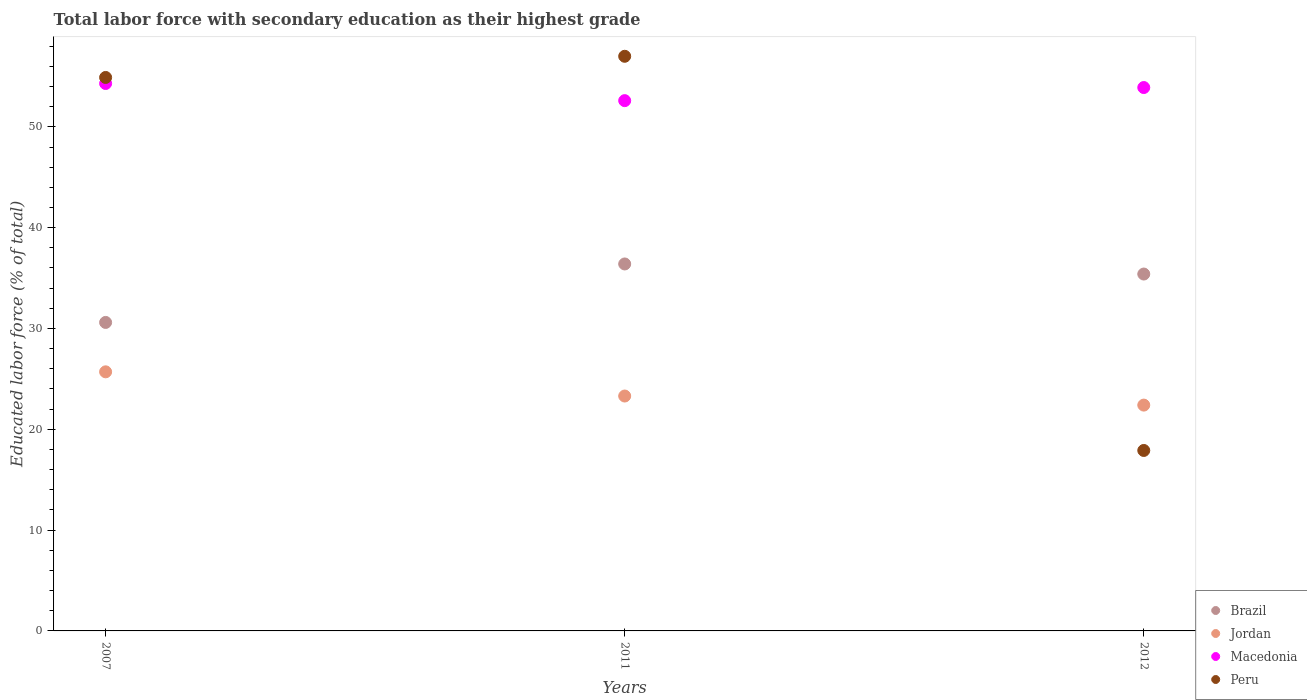How many different coloured dotlines are there?
Keep it short and to the point. 4. What is the percentage of total labor force with primary education in Brazil in 2011?
Make the answer very short. 36.4. Across all years, what is the maximum percentage of total labor force with primary education in Peru?
Provide a succinct answer. 57. Across all years, what is the minimum percentage of total labor force with primary education in Jordan?
Ensure brevity in your answer.  22.4. In which year was the percentage of total labor force with primary education in Peru maximum?
Offer a terse response. 2011. What is the total percentage of total labor force with primary education in Jordan in the graph?
Offer a terse response. 71.4. What is the difference between the percentage of total labor force with primary education in Peru in 2007 and that in 2012?
Your answer should be compact. 37. What is the difference between the percentage of total labor force with primary education in Peru in 2007 and the percentage of total labor force with primary education in Jordan in 2012?
Ensure brevity in your answer.  32.5. What is the average percentage of total labor force with primary education in Brazil per year?
Provide a short and direct response. 34.13. In the year 2012, what is the difference between the percentage of total labor force with primary education in Macedonia and percentage of total labor force with primary education in Jordan?
Your answer should be compact. 31.5. What is the ratio of the percentage of total labor force with primary education in Peru in 2007 to that in 2011?
Make the answer very short. 0.96. Is the percentage of total labor force with primary education in Macedonia in 2007 less than that in 2012?
Offer a terse response. No. What is the difference between the highest and the second highest percentage of total labor force with primary education in Jordan?
Provide a succinct answer. 2.4. What is the difference between the highest and the lowest percentage of total labor force with primary education in Jordan?
Offer a terse response. 3.3. In how many years, is the percentage of total labor force with primary education in Jordan greater than the average percentage of total labor force with primary education in Jordan taken over all years?
Your response must be concise. 1. Is it the case that in every year, the sum of the percentage of total labor force with primary education in Macedonia and percentage of total labor force with primary education in Brazil  is greater than the percentage of total labor force with primary education in Jordan?
Ensure brevity in your answer.  Yes. Does the percentage of total labor force with primary education in Jordan monotonically increase over the years?
Offer a terse response. No. Is the percentage of total labor force with primary education in Macedonia strictly greater than the percentage of total labor force with primary education in Brazil over the years?
Offer a very short reply. Yes. What is the difference between two consecutive major ticks on the Y-axis?
Offer a very short reply. 10. Are the values on the major ticks of Y-axis written in scientific E-notation?
Your answer should be compact. No. Does the graph contain any zero values?
Make the answer very short. No. How are the legend labels stacked?
Make the answer very short. Vertical. What is the title of the graph?
Your answer should be very brief. Total labor force with secondary education as their highest grade. What is the label or title of the X-axis?
Your answer should be compact. Years. What is the label or title of the Y-axis?
Provide a short and direct response. Educated labor force (% of total). What is the Educated labor force (% of total) in Brazil in 2007?
Ensure brevity in your answer.  30.6. What is the Educated labor force (% of total) of Jordan in 2007?
Ensure brevity in your answer.  25.7. What is the Educated labor force (% of total) of Macedonia in 2007?
Your answer should be very brief. 54.3. What is the Educated labor force (% of total) of Peru in 2007?
Your response must be concise. 54.9. What is the Educated labor force (% of total) of Brazil in 2011?
Offer a very short reply. 36.4. What is the Educated labor force (% of total) in Jordan in 2011?
Ensure brevity in your answer.  23.3. What is the Educated labor force (% of total) of Macedonia in 2011?
Provide a short and direct response. 52.6. What is the Educated labor force (% of total) in Brazil in 2012?
Offer a very short reply. 35.4. What is the Educated labor force (% of total) in Jordan in 2012?
Offer a very short reply. 22.4. What is the Educated labor force (% of total) in Macedonia in 2012?
Keep it short and to the point. 53.9. What is the Educated labor force (% of total) of Peru in 2012?
Offer a very short reply. 17.9. Across all years, what is the maximum Educated labor force (% of total) of Brazil?
Give a very brief answer. 36.4. Across all years, what is the maximum Educated labor force (% of total) in Jordan?
Keep it short and to the point. 25.7. Across all years, what is the maximum Educated labor force (% of total) of Macedonia?
Keep it short and to the point. 54.3. Across all years, what is the maximum Educated labor force (% of total) in Peru?
Your answer should be very brief. 57. Across all years, what is the minimum Educated labor force (% of total) of Brazil?
Your answer should be compact. 30.6. Across all years, what is the minimum Educated labor force (% of total) in Jordan?
Provide a short and direct response. 22.4. Across all years, what is the minimum Educated labor force (% of total) of Macedonia?
Provide a short and direct response. 52.6. Across all years, what is the minimum Educated labor force (% of total) of Peru?
Your answer should be very brief. 17.9. What is the total Educated labor force (% of total) of Brazil in the graph?
Provide a succinct answer. 102.4. What is the total Educated labor force (% of total) of Jordan in the graph?
Offer a very short reply. 71.4. What is the total Educated labor force (% of total) of Macedonia in the graph?
Offer a very short reply. 160.8. What is the total Educated labor force (% of total) in Peru in the graph?
Keep it short and to the point. 129.8. What is the difference between the Educated labor force (% of total) of Jordan in 2007 and that in 2011?
Provide a succinct answer. 2.4. What is the difference between the Educated labor force (% of total) of Peru in 2007 and that in 2011?
Your response must be concise. -2.1. What is the difference between the Educated labor force (% of total) of Macedonia in 2007 and that in 2012?
Provide a succinct answer. 0.4. What is the difference between the Educated labor force (% of total) in Peru in 2007 and that in 2012?
Your answer should be very brief. 37. What is the difference between the Educated labor force (% of total) in Jordan in 2011 and that in 2012?
Ensure brevity in your answer.  0.9. What is the difference between the Educated labor force (% of total) of Macedonia in 2011 and that in 2012?
Offer a terse response. -1.3. What is the difference between the Educated labor force (% of total) in Peru in 2011 and that in 2012?
Your response must be concise. 39.1. What is the difference between the Educated labor force (% of total) of Brazil in 2007 and the Educated labor force (% of total) of Peru in 2011?
Offer a very short reply. -26.4. What is the difference between the Educated labor force (% of total) in Jordan in 2007 and the Educated labor force (% of total) in Macedonia in 2011?
Offer a very short reply. -26.9. What is the difference between the Educated labor force (% of total) of Jordan in 2007 and the Educated labor force (% of total) of Peru in 2011?
Keep it short and to the point. -31.3. What is the difference between the Educated labor force (% of total) of Macedonia in 2007 and the Educated labor force (% of total) of Peru in 2011?
Offer a terse response. -2.7. What is the difference between the Educated labor force (% of total) in Brazil in 2007 and the Educated labor force (% of total) in Macedonia in 2012?
Your answer should be compact. -23.3. What is the difference between the Educated labor force (% of total) of Jordan in 2007 and the Educated labor force (% of total) of Macedonia in 2012?
Keep it short and to the point. -28.2. What is the difference between the Educated labor force (% of total) of Jordan in 2007 and the Educated labor force (% of total) of Peru in 2012?
Ensure brevity in your answer.  7.8. What is the difference between the Educated labor force (% of total) in Macedonia in 2007 and the Educated labor force (% of total) in Peru in 2012?
Provide a succinct answer. 36.4. What is the difference between the Educated labor force (% of total) in Brazil in 2011 and the Educated labor force (% of total) in Jordan in 2012?
Offer a terse response. 14. What is the difference between the Educated labor force (% of total) in Brazil in 2011 and the Educated labor force (% of total) in Macedonia in 2012?
Provide a short and direct response. -17.5. What is the difference between the Educated labor force (% of total) of Jordan in 2011 and the Educated labor force (% of total) of Macedonia in 2012?
Provide a short and direct response. -30.6. What is the difference between the Educated labor force (% of total) in Jordan in 2011 and the Educated labor force (% of total) in Peru in 2012?
Offer a very short reply. 5.4. What is the difference between the Educated labor force (% of total) in Macedonia in 2011 and the Educated labor force (% of total) in Peru in 2012?
Offer a very short reply. 34.7. What is the average Educated labor force (% of total) in Brazil per year?
Offer a very short reply. 34.13. What is the average Educated labor force (% of total) in Jordan per year?
Offer a very short reply. 23.8. What is the average Educated labor force (% of total) of Macedonia per year?
Your answer should be compact. 53.6. What is the average Educated labor force (% of total) of Peru per year?
Make the answer very short. 43.27. In the year 2007, what is the difference between the Educated labor force (% of total) of Brazil and Educated labor force (% of total) of Macedonia?
Ensure brevity in your answer.  -23.7. In the year 2007, what is the difference between the Educated labor force (% of total) of Brazil and Educated labor force (% of total) of Peru?
Provide a short and direct response. -24.3. In the year 2007, what is the difference between the Educated labor force (% of total) in Jordan and Educated labor force (% of total) in Macedonia?
Your response must be concise. -28.6. In the year 2007, what is the difference between the Educated labor force (% of total) in Jordan and Educated labor force (% of total) in Peru?
Ensure brevity in your answer.  -29.2. In the year 2007, what is the difference between the Educated labor force (% of total) in Macedonia and Educated labor force (% of total) in Peru?
Provide a succinct answer. -0.6. In the year 2011, what is the difference between the Educated labor force (% of total) of Brazil and Educated labor force (% of total) of Jordan?
Give a very brief answer. 13.1. In the year 2011, what is the difference between the Educated labor force (% of total) in Brazil and Educated labor force (% of total) in Macedonia?
Keep it short and to the point. -16.2. In the year 2011, what is the difference between the Educated labor force (% of total) in Brazil and Educated labor force (% of total) in Peru?
Your answer should be compact. -20.6. In the year 2011, what is the difference between the Educated labor force (% of total) in Jordan and Educated labor force (% of total) in Macedonia?
Provide a short and direct response. -29.3. In the year 2011, what is the difference between the Educated labor force (% of total) in Jordan and Educated labor force (% of total) in Peru?
Provide a short and direct response. -33.7. In the year 2012, what is the difference between the Educated labor force (% of total) in Brazil and Educated labor force (% of total) in Jordan?
Keep it short and to the point. 13. In the year 2012, what is the difference between the Educated labor force (% of total) in Brazil and Educated labor force (% of total) in Macedonia?
Give a very brief answer. -18.5. In the year 2012, what is the difference between the Educated labor force (% of total) of Jordan and Educated labor force (% of total) of Macedonia?
Keep it short and to the point. -31.5. In the year 2012, what is the difference between the Educated labor force (% of total) of Macedonia and Educated labor force (% of total) of Peru?
Your answer should be very brief. 36. What is the ratio of the Educated labor force (% of total) in Brazil in 2007 to that in 2011?
Provide a succinct answer. 0.84. What is the ratio of the Educated labor force (% of total) in Jordan in 2007 to that in 2011?
Your answer should be very brief. 1.1. What is the ratio of the Educated labor force (% of total) of Macedonia in 2007 to that in 2011?
Your response must be concise. 1.03. What is the ratio of the Educated labor force (% of total) in Peru in 2007 to that in 2011?
Give a very brief answer. 0.96. What is the ratio of the Educated labor force (% of total) of Brazil in 2007 to that in 2012?
Your answer should be compact. 0.86. What is the ratio of the Educated labor force (% of total) of Jordan in 2007 to that in 2012?
Offer a terse response. 1.15. What is the ratio of the Educated labor force (% of total) in Macedonia in 2007 to that in 2012?
Offer a very short reply. 1.01. What is the ratio of the Educated labor force (% of total) of Peru in 2007 to that in 2012?
Offer a very short reply. 3.07. What is the ratio of the Educated labor force (% of total) of Brazil in 2011 to that in 2012?
Keep it short and to the point. 1.03. What is the ratio of the Educated labor force (% of total) in Jordan in 2011 to that in 2012?
Make the answer very short. 1.04. What is the ratio of the Educated labor force (% of total) in Macedonia in 2011 to that in 2012?
Provide a short and direct response. 0.98. What is the ratio of the Educated labor force (% of total) in Peru in 2011 to that in 2012?
Your answer should be very brief. 3.18. What is the difference between the highest and the second highest Educated labor force (% of total) in Jordan?
Provide a short and direct response. 2.4. What is the difference between the highest and the lowest Educated labor force (% of total) of Peru?
Your response must be concise. 39.1. 